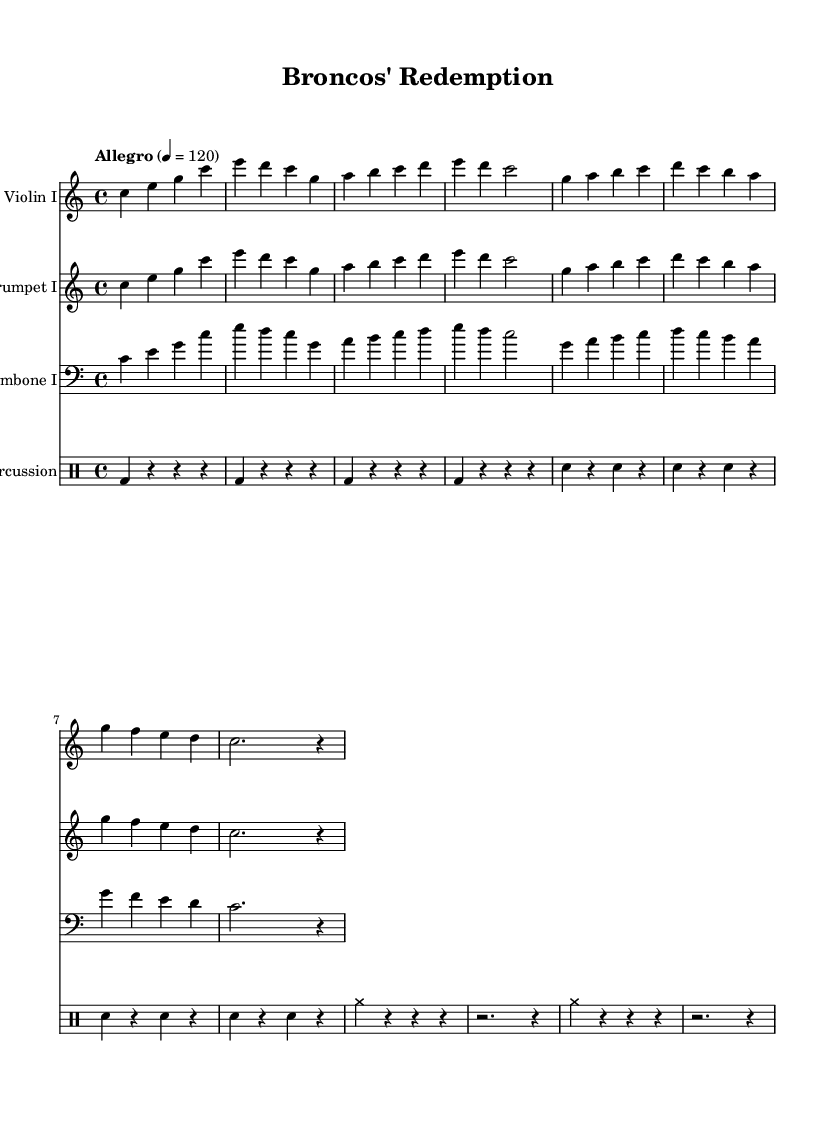What is the key signature of this music? The key signature is indicated at the beginning of the staff, where it shows no sharps or flats. This confirms that the key is C major.
Answer: C major What is the time signature of this music? The time signature is displayed at the beginning as "4/4," meaning there are four beats in each measure, and the quarter note gets one beat.
Answer: 4/4 What is the tempo marking for this piece? The tempo marking is written above the staff with the term "Allegro" followed by the metronome mark "4 = 120," indicating a fast tempo.
Answer: Allegro, 4 = 120 How many measures are there in the first section of the score? By counting the vertical bar lines separating the measures in the first section, we find a total of eight measures.
Answer: 8 Which instrument is playing in the bass clef? The staff marked with a bass clef is designated for the trombone, indicating it plays lower pitches compared to the other instruments.
Answer: Trombone I What type of percussion is utilized in this score? The percussion section comprises bass drum and snare drum notes, indicated by "bd" for bass drum and "sn" for snare drum in the drummode.
Answer: Bass drum, snare drum What is the dynamic level indicated in the music? The score does not specify any dynamic markings; therefore, it is indicative of a typical orchestral score where dynamics may be interpreted by the conductor and performers.
Answer: No dynamics indicated 